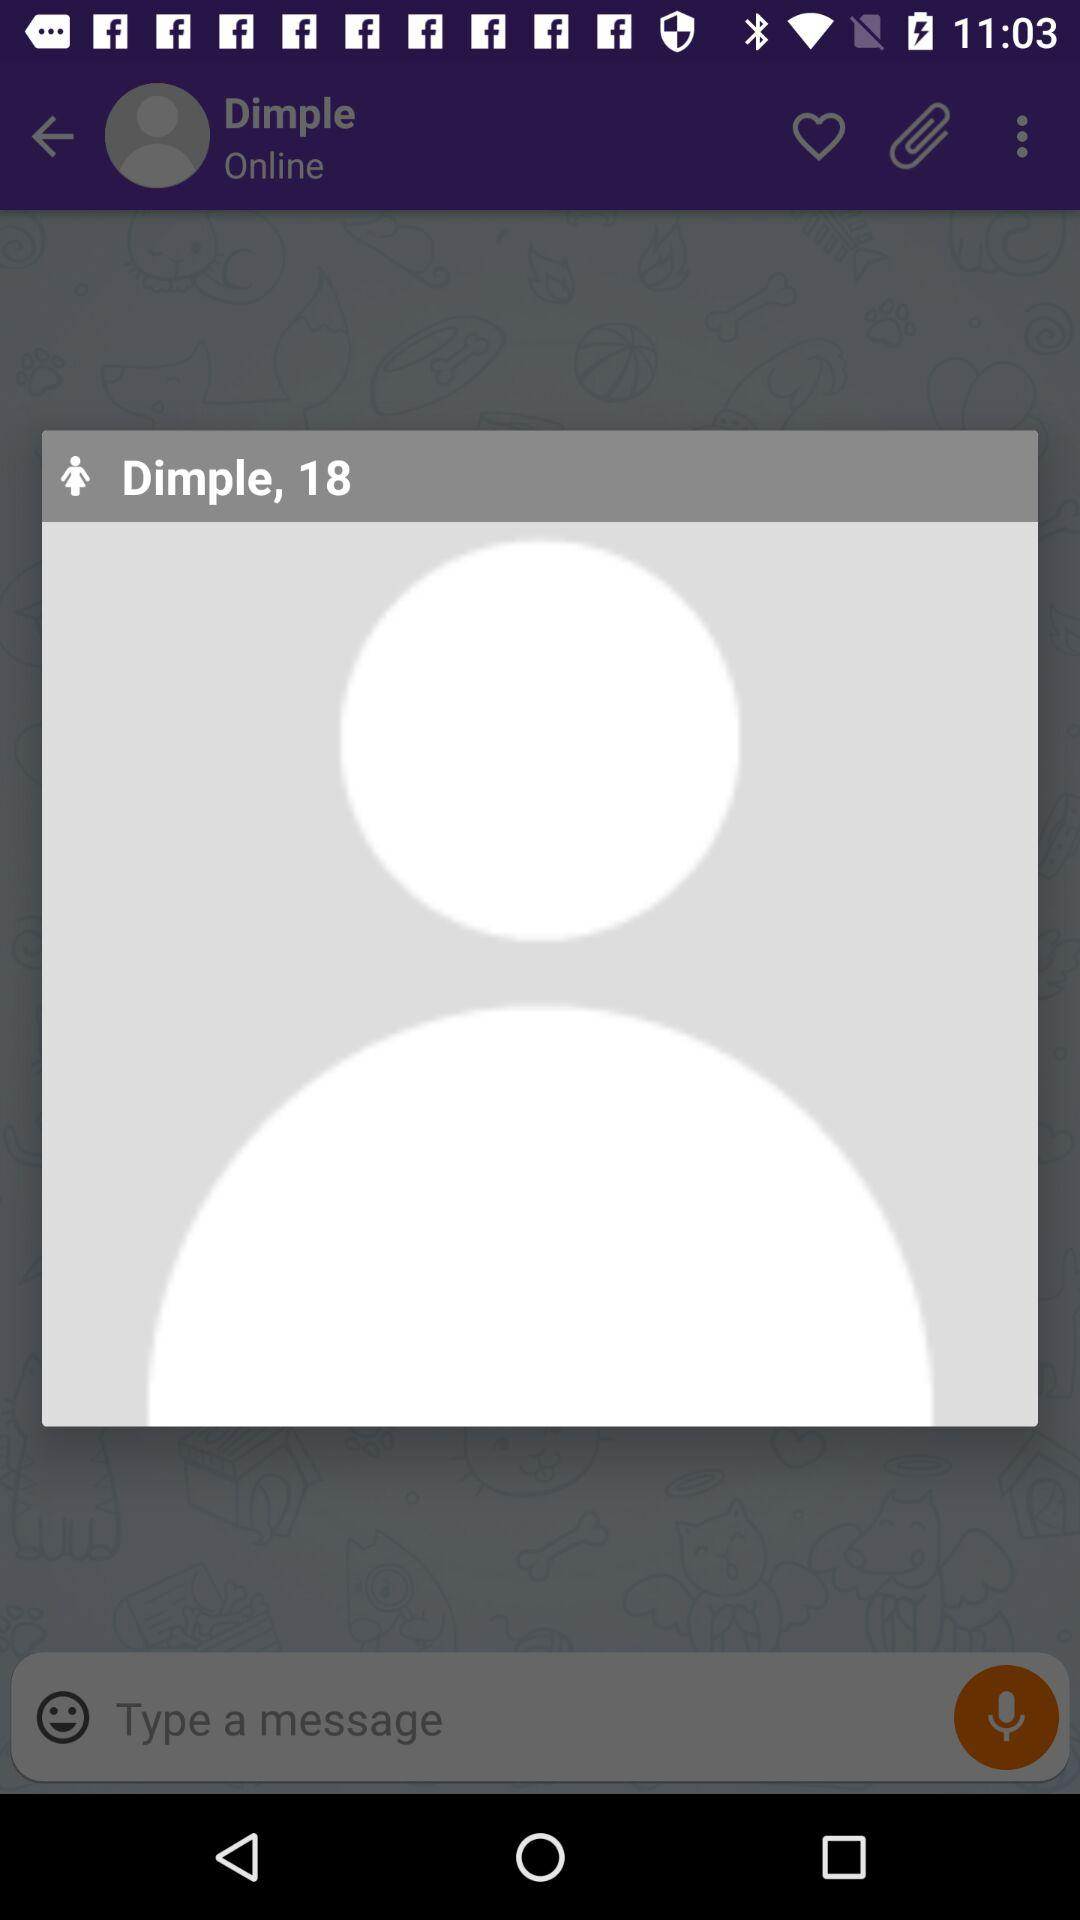What is the name of the user? The name of the user is Dimple. 